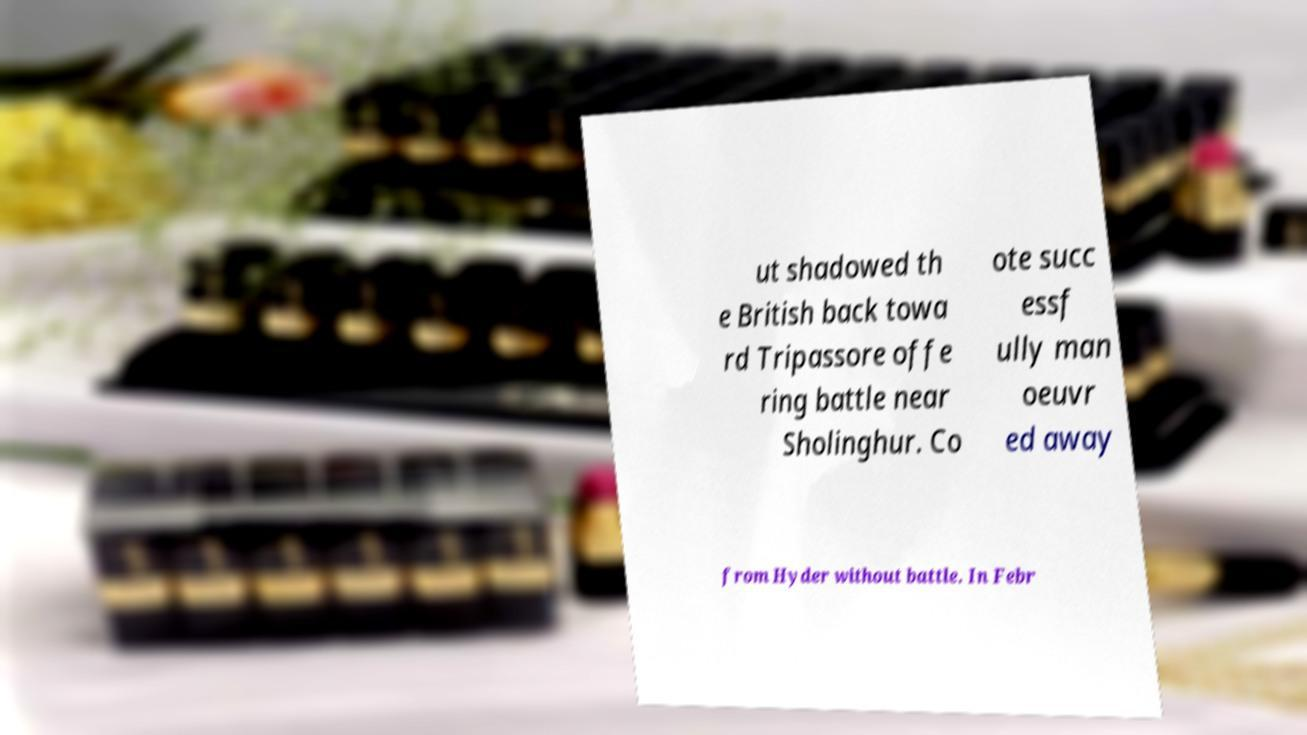There's text embedded in this image that I need extracted. Can you transcribe it verbatim? ut shadowed th e British back towa rd Tripassore offe ring battle near Sholinghur. Co ote succ essf ully man oeuvr ed away from Hyder without battle. In Febr 